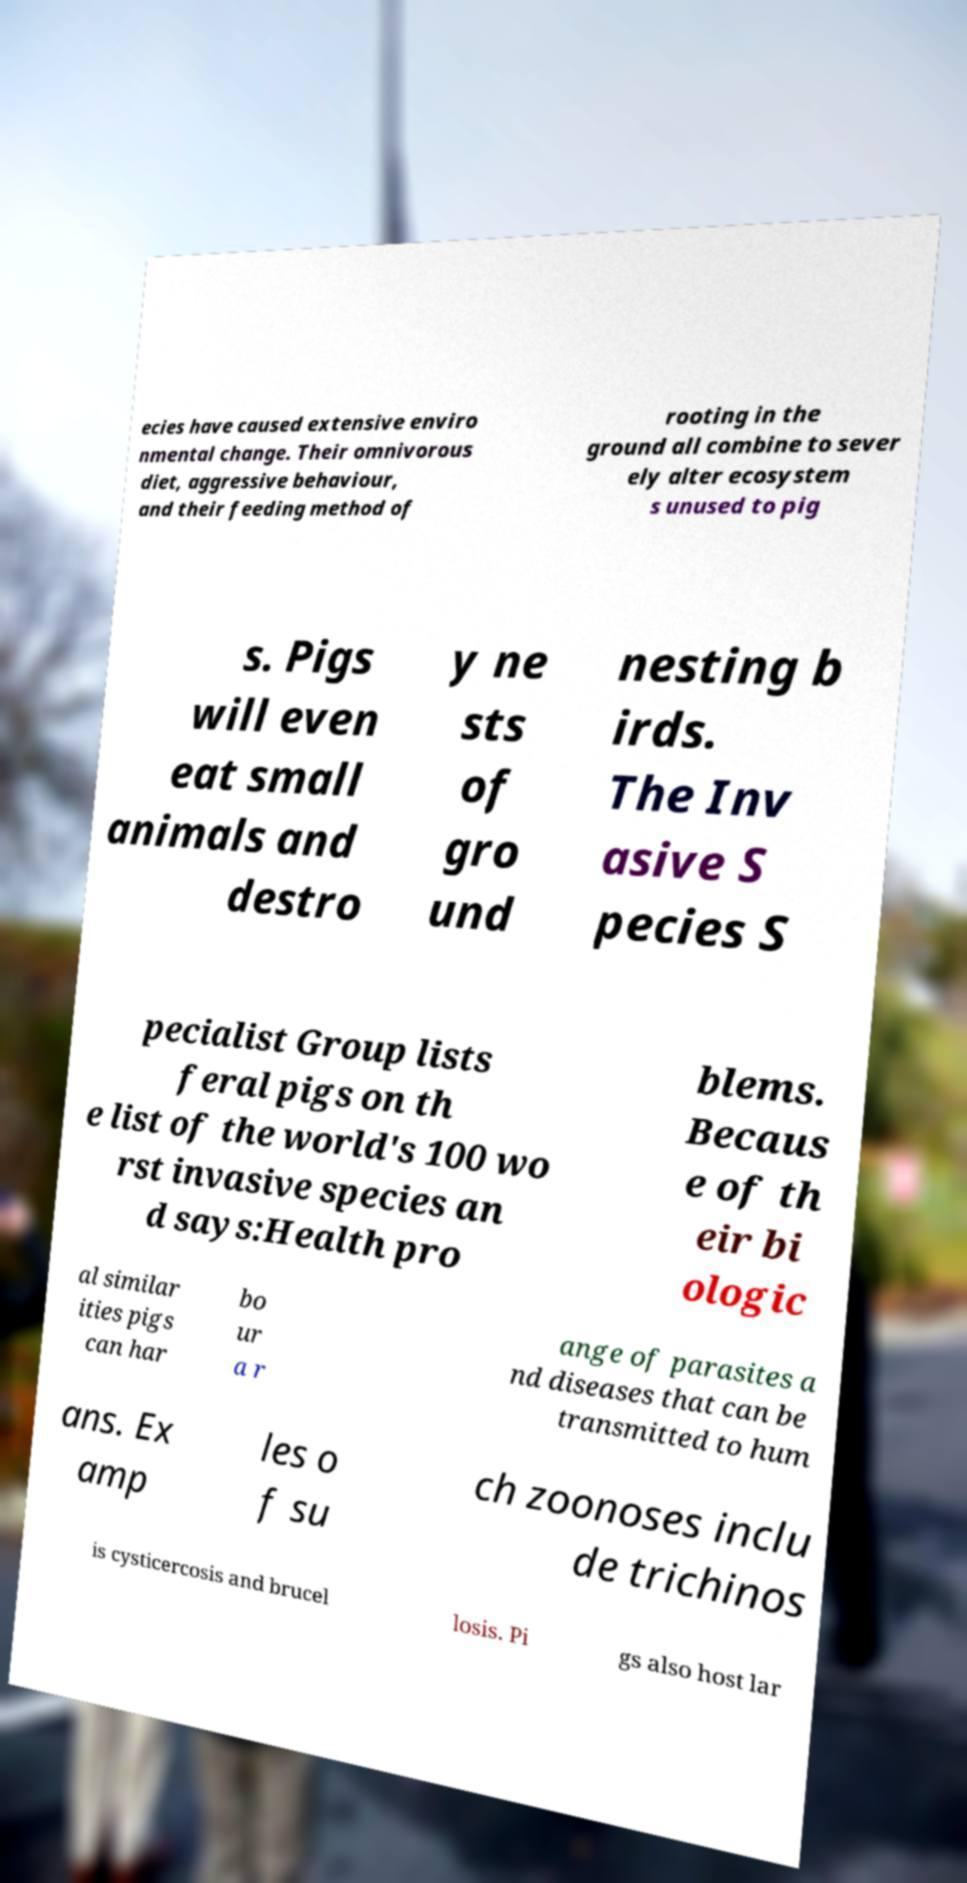Could you extract and type out the text from this image? ecies have caused extensive enviro nmental change. Their omnivorous diet, aggressive behaviour, and their feeding method of rooting in the ground all combine to sever ely alter ecosystem s unused to pig s. Pigs will even eat small animals and destro y ne sts of gro und nesting b irds. The Inv asive S pecies S pecialist Group lists feral pigs on th e list of the world's 100 wo rst invasive species an d says:Health pro blems. Becaus e of th eir bi ologic al similar ities pigs can har bo ur a r ange of parasites a nd diseases that can be transmitted to hum ans. Ex amp les o f su ch zoonoses inclu de trichinos is cysticercosis and brucel losis. Pi gs also host lar 